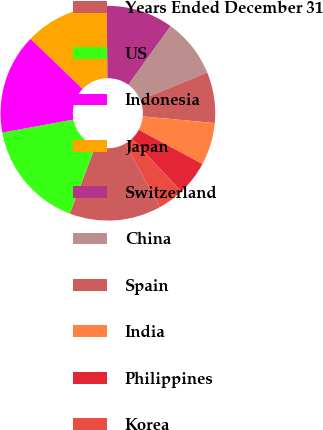Convert chart. <chart><loc_0><loc_0><loc_500><loc_500><pie_chart><fcel>Years Ended December 31<fcel>US<fcel>Indonesia<fcel>Japan<fcel>Switzerland<fcel>China<fcel>Spain<fcel>India<fcel>Philippines<fcel>Korea<nl><fcel>13.86%<fcel>16.34%<fcel>15.1%<fcel>12.61%<fcel>10.12%<fcel>8.88%<fcel>7.64%<fcel>6.39%<fcel>5.15%<fcel>3.91%<nl></chart> 